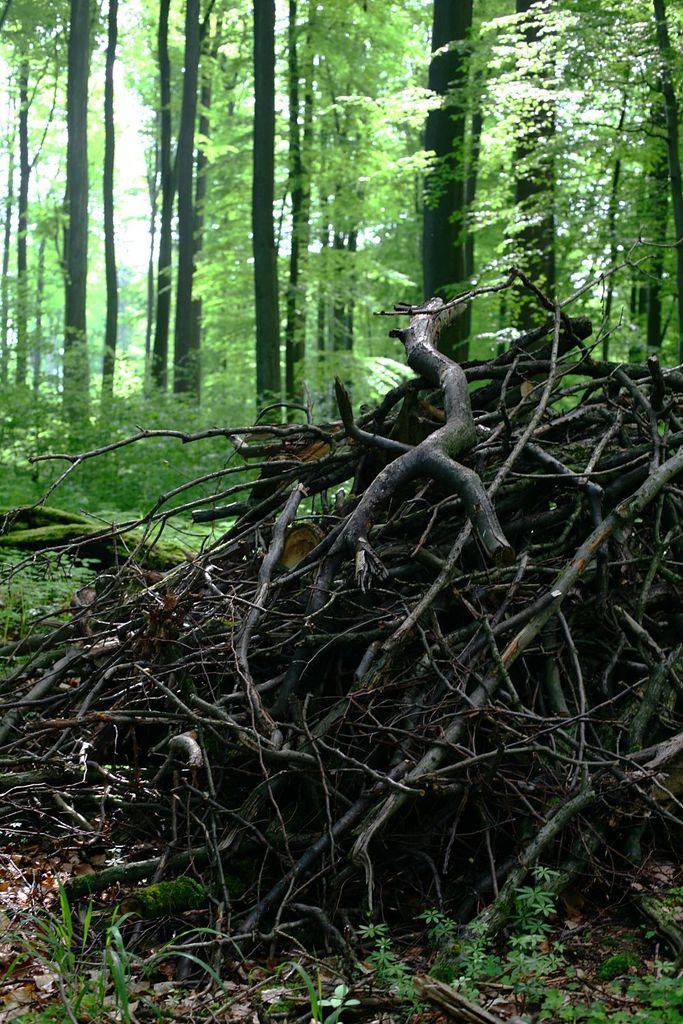Could you give a brief overview of what you see in this image? As we can see in the image there are tree stems, plants and trees. 